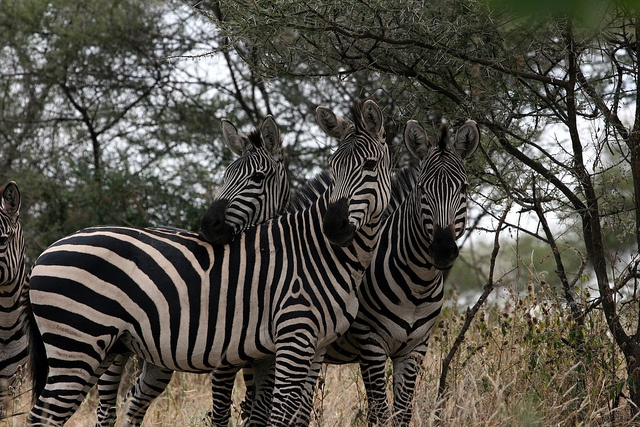Describe the objects in this image and their specific colors. I can see zebra in gray, black, and darkgray tones, zebra in gray and black tones, zebra in gray, black, and darkgray tones, and zebra in gray and black tones in this image. 